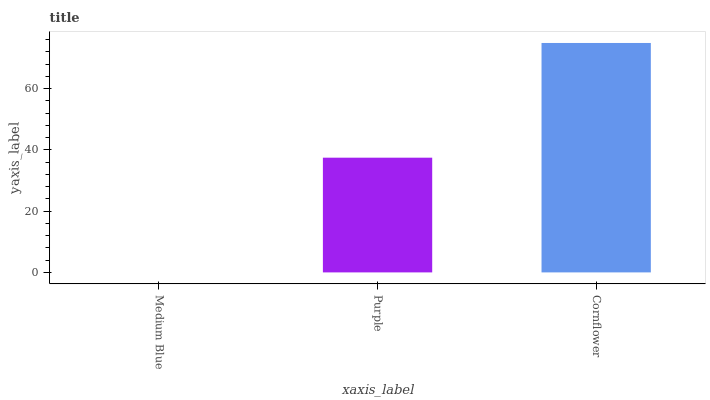Is Purple the minimum?
Answer yes or no. No. Is Purple the maximum?
Answer yes or no. No. Is Purple greater than Medium Blue?
Answer yes or no. Yes. Is Medium Blue less than Purple?
Answer yes or no. Yes. Is Medium Blue greater than Purple?
Answer yes or no. No. Is Purple less than Medium Blue?
Answer yes or no. No. Is Purple the high median?
Answer yes or no. Yes. Is Purple the low median?
Answer yes or no. Yes. Is Cornflower the high median?
Answer yes or no. No. Is Medium Blue the low median?
Answer yes or no. No. 